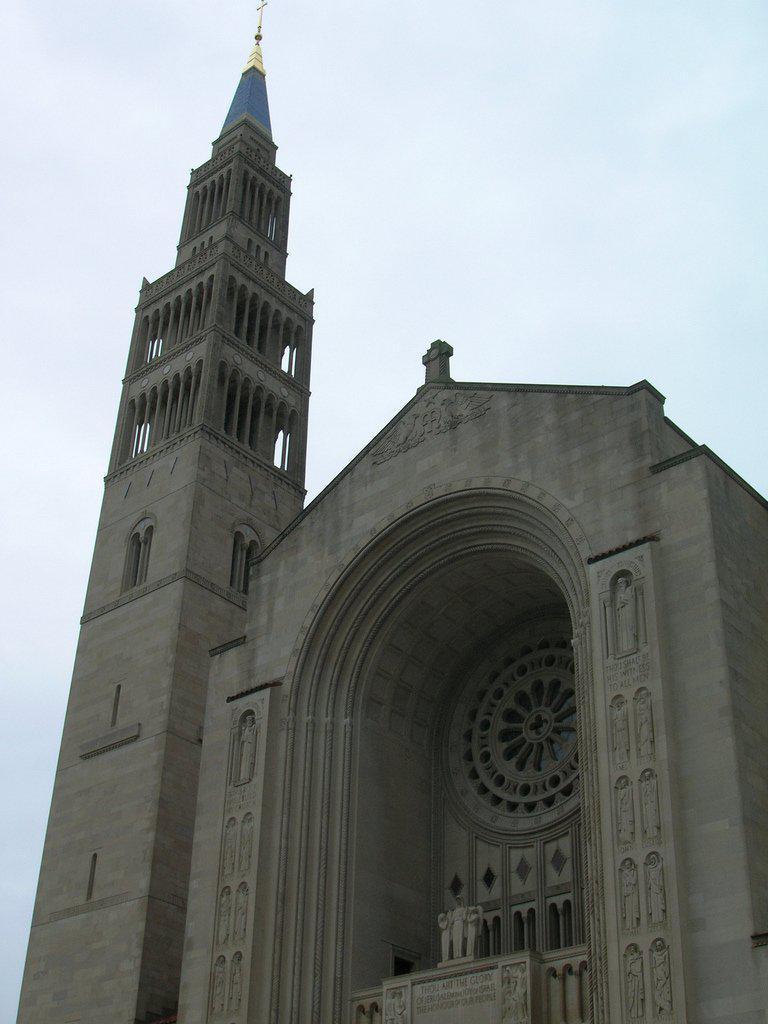Please provide a concise description of this image. On the left side, there is a tower. Beside this town, there is a building. In the background, there are clouds in the sky. 